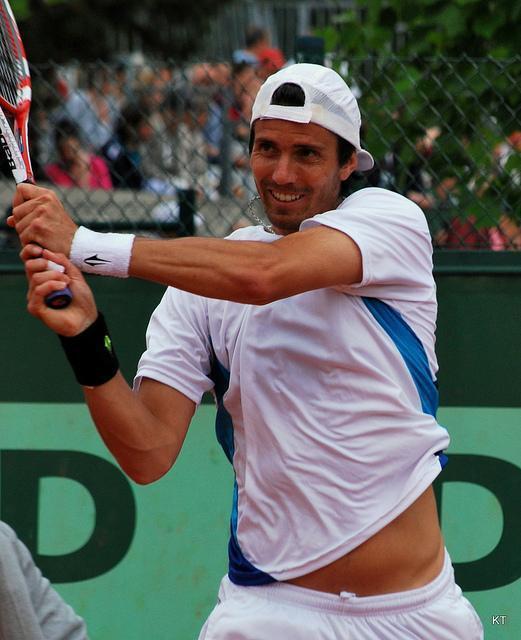How many gloves is the player wearing?
Give a very brief answer. 0. How many fingers is the man holding up?
Give a very brief answer. 0. How many people are in the picture?
Give a very brief answer. 3. 